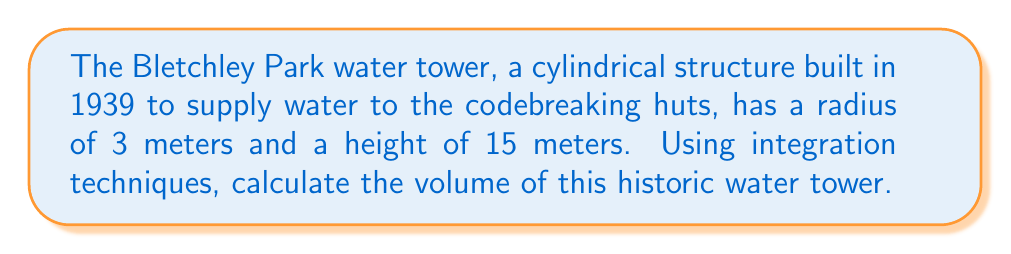Can you answer this question? To determine the volume of a cylindrical water tower using integration techniques, we follow these steps:

1) The volume of a cylinder can be found by integrating the area of circular cross-sections along the height of the cylinder.

2) The area of a circular cross-section is given by $A = \pi r^2$, where $r$ is the radius.

3) In this case, the radius is constant at 3 meters throughout the height of the cylinder.

4) We set up the integral:

   $$V = \int_0^h A(z) dz = \int_0^h \pi r^2 dz$$

   where $h$ is the height of the cylinder and $z$ is the variable of integration representing the height.

5) Substituting the given values:

   $$V = \int_0^{15} \pi (3)^2 dz$$

6) Simplify:

   $$V = 9\pi \int_0^{15} dz$$

7) Evaluate the integral:

   $$V = 9\pi [z]_0^{15} = 9\pi (15 - 0) = 135\pi$$

8) This gives us the volume in cubic meters.

9) If we want to calculate the exact value, we multiply by $\pi$:

   $$V = 135 \cdot \pi \approx 423.89 \text{ m}^3$$

Thus, the volume of the Bletchley Park water tower is $135\pi$ cubic meters or approximately 423.89 cubic meters.
Answer: $135\pi \text{ m}^3$ or approximately $423.89 \text{ m}^3$ 